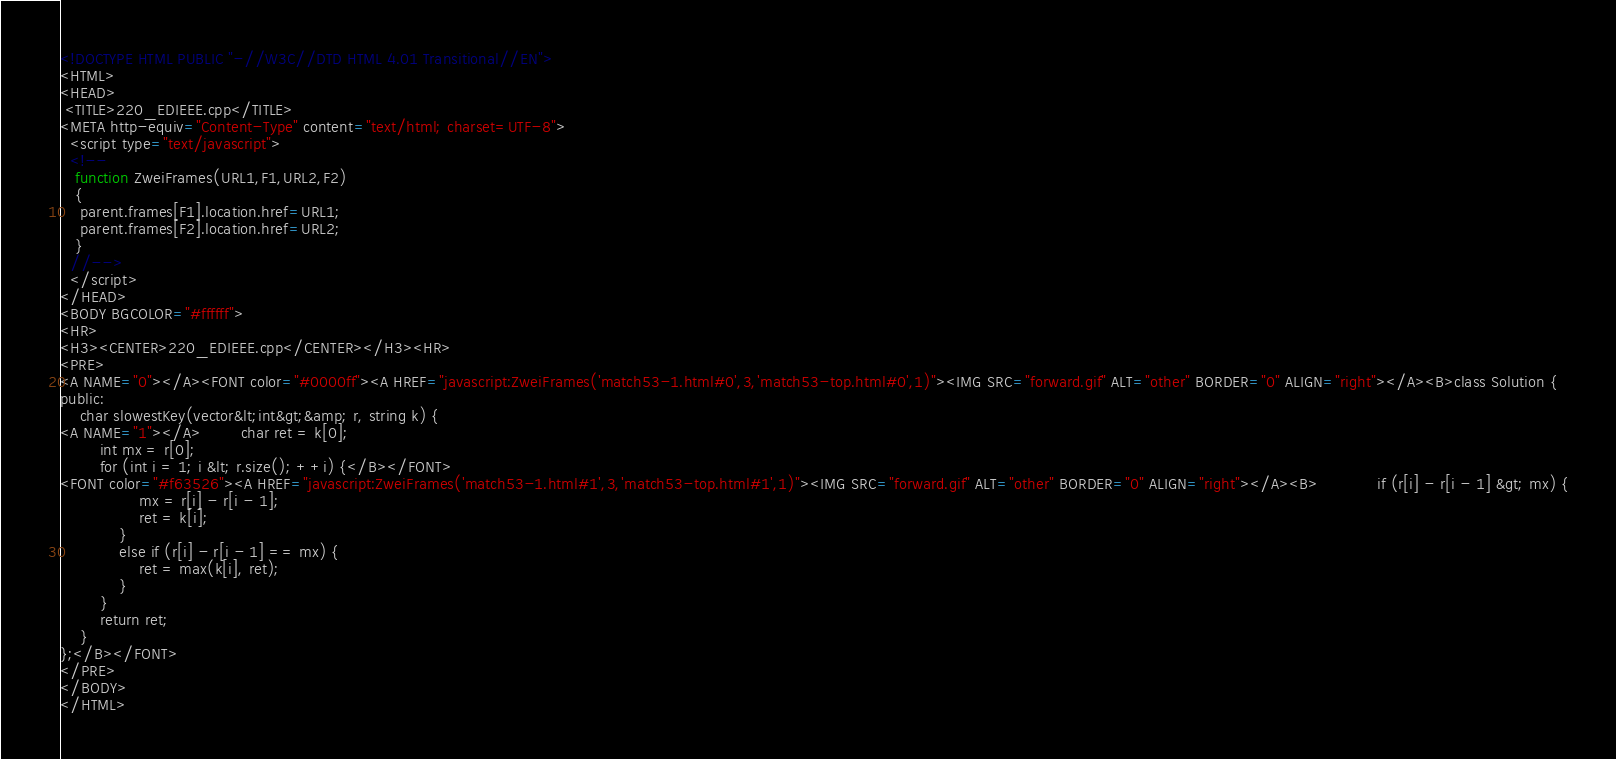Convert code to text. <code><loc_0><loc_0><loc_500><loc_500><_HTML_><!DOCTYPE HTML PUBLIC "-//W3C//DTD HTML 4.01 Transitional//EN">
<HTML>
<HEAD>
 <TITLE>220_EDIEEE.cpp</TITLE>
<META http-equiv="Content-Type" content="text/html; charset=UTF-8">
  <script type="text/javascript">
  <!--
   function ZweiFrames(URL1,F1,URL2,F2)
   {
    parent.frames[F1].location.href=URL1;
    parent.frames[F2].location.href=URL2;
   }
  //-->
  </script>
</HEAD>
<BODY BGCOLOR="#ffffff">
<HR>
<H3><CENTER>220_EDIEEE.cpp</CENTER></H3><HR>
<PRE>
<A NAME="0"></A><FONT color="#0000ff"><A HREF="javascript:ZweiFrames('match53-1.html#0',3,'match53-top.html#0',1)"><IMG SRC="forward.gif" ALT="other" BORDER="0" ALIGN="right"></A><B>class Solution {
public:
    char slowestKey(vector&lt;int&gt;&amp; r, string k) {
<A NAME="1"></A>        char ret = k[0];
        int mx = r[0];
        for (int i = 1; i &lt; r.size(); ++i) {</B></FONT>
<FONT color="#f63526"><A HREF="javascript:ZweiFrames('match53-1.html#1',3,'match53-top.html#1',1)"><IMG SRC="forward.gif" ALT="other" BORDER="0" ALIGN="right"></A><B>            if (r[i] - r[i - 1] &gt; mx) {
                mx = r[i] - r[i - 1];
                ret = k[i];
            } 
            else if (r[i] - r[i - 1] == mx) {
                ret = max(k[i], ret);
            }
        }
        return ret;
    }
};</B></FONT>
</PRE>
</BODY>
</HTML>
</code> 